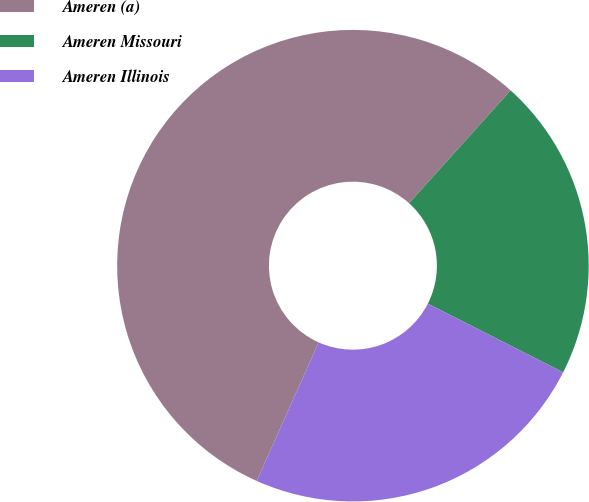Convert chart. <chart><loc_0><loc_0><loc_500><loc_500><pie_chart><fcel>Ameren (a)<fcel>Ameren Missouri<fcel>Ameren Illinois<nl><fcel>54.97%<fcel>20.81%<fcel>24.22%<nl></chart> 